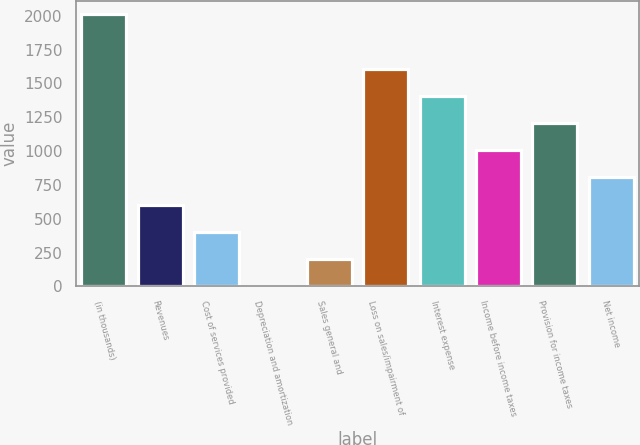Convert chart. <chart><loc_0><loc_0><loc_500><loc_500><bar_chart><fcel>(in thousands)<fcel>Revenues<fcel>Cost of services provided<fcel>Depreciation and amortization<fcel>Sales general and<fcel>Loss on sales/impairment of<fcel>Interest expense<fcel>Income before income taxes<fcel>Provision for income taxes<fcel>Net income<nl><fcel>2010<fcel>604.4<fcel>403.6<fcel>2<fcel>202.8<fcel>1608.4<fcel>1407.6<fcel>1006<fcel>1206.8<fcel>805.2<nl></chart> 